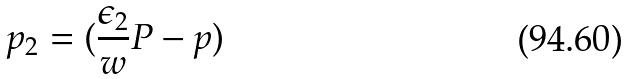Convert formula to latex. <formula><loc_0><loc_0><loc_500><loc_500>p _ { 2 } = ( \frac { \epsilon _ { 2 } } { w } P - p )</formula> 